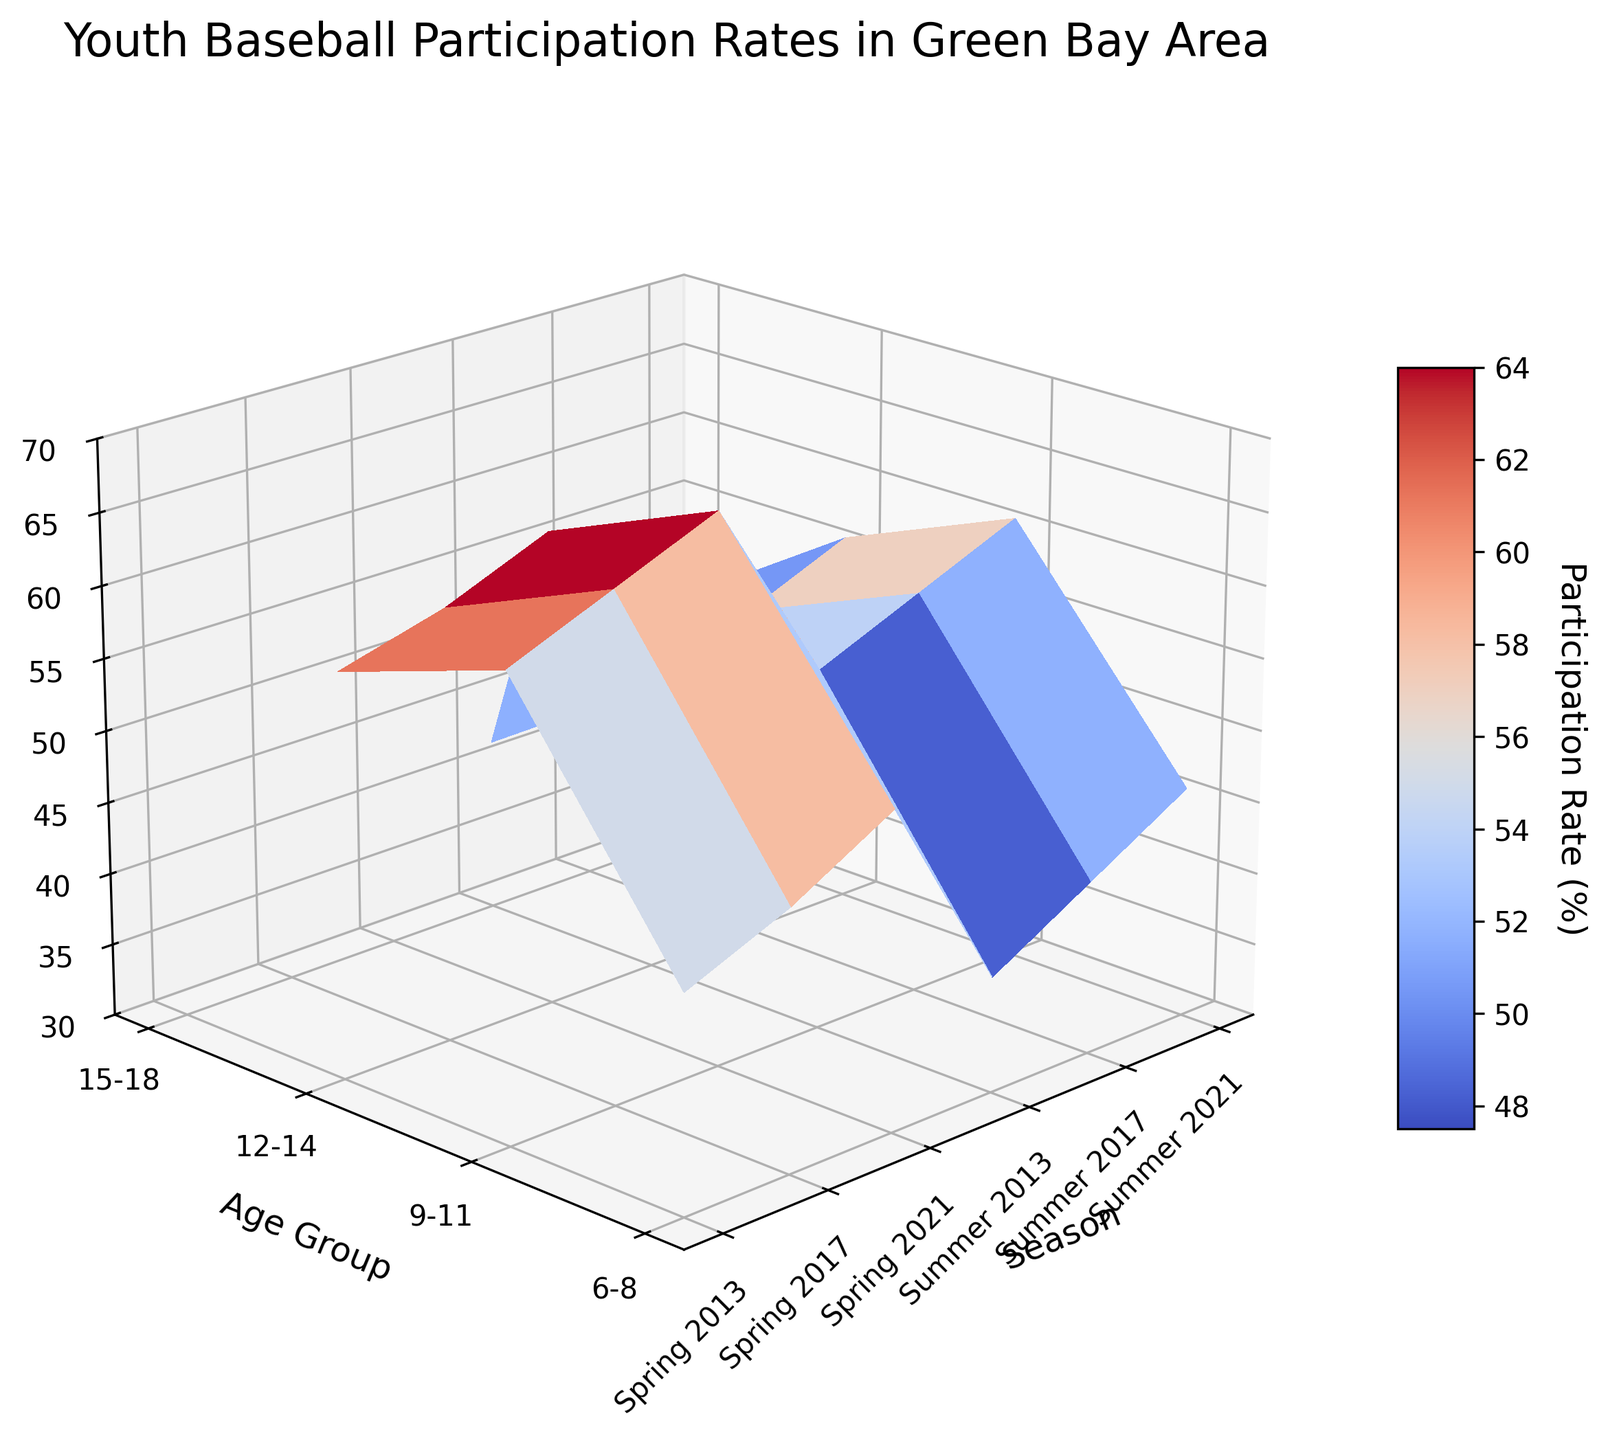Which age group has the highest participation rate in 2021? The age group "9-11" in Little League shows the highest participation rate in 2021. This is visible on the 3D surface plot, where a peak appears in this section.
Answer: 9-11 In general, how do the participation rates of the "6-8" age group in YMCA change from 2013 to 2021? The participation rate for the "6-8" age group in the YMCA sees an increase from 38% in 2013 to 46% in 2021. This increasing trend can be identified from the surface plot by observing the rise in the corresponding region over the years.
Answer: Increase Which league type shows the most significant increase in participation for the "6-8" age group over the last decade? Comparing the slopes of participation rates for different leagues in the "6-8" age group, the Little League shows a more significant increase from 45% in 2013 to 52% in 2021, while the YMCA increases from 38% to 46%. Thus, the Little League has a more significant increase.
Answer: Little League Compare the participation rates of the "9-11" age group in Little League and Babe Ruth League for the year 2021. Which one is higher? In 2021, the participation rate for the "9-11" age group in Little League is 68%, while in the Babe Ruth League, it is 61%. By comparing the heights of the surfaces for these points, we can see that Little League is higher.
Answer: Little League How do the participation rates of the "12-14" age group in Babe Ruth League change from 2013 to 2021? The participation rate for the "12-14" age group in Babe Ruth League increases from 50% in 2013 to 56% in 2021. This trend can be seen by following the elevation changes in the corresponding section of the surface plot.
Answer: Increase What is the average participation rate of the "15-18" age group in American Legion over the years listed? The participation rates are 42%, 45%, and 48% for the years 2013, 2017, and 2021. Calculating the average: (42 + 45 + 48) / 3 = 45%.
Answer: 45% Which age group shows the least variation in participation rates across different leagues and seasons? The "15-18" age group in American Legion shows the least variation as their participation rates vary from 42% to 48%, which is a smaller range compared to other age groups. This can be observed by comparing the smoothness of the surfaces in different regions.
Answer: 15-18 What trend can be seen in the participation rate of the "12-14" age group in Little League from 2013 to 2021? The trend shows an increase in participation rates for the "12-14" age group in Little League from 58% in 2013 to 63% in 2021. This is evident by the rising surface in the corresponding area.
Answer: Increasing 